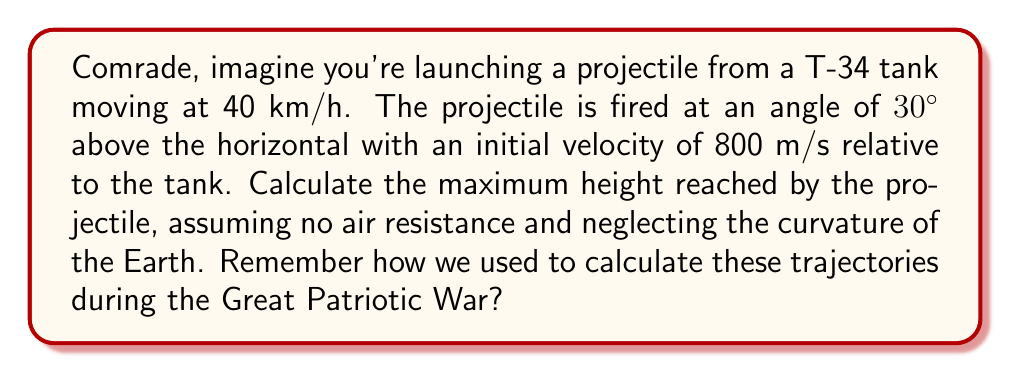Could you help me with this problem? Let's approach this step-by-step, tovarishch:

1) First, we need to determine the initial velocity components of the projectile relative to the ground. The tank's velocity adds to the horizontal component.

   Tank velocity: $v_t = 40 \text{ km/h} = 11.11 \text{ m/s}$
   
   Initial velocity components:
   $$v_{x0} = 800 \cos(30°) + 11.11 = 692.82 + 11.11 = 703.93 \text{ m/s}$$
   $$v_{y0} = 800 \sin(30°) = 400 \text{ m/s}$$

2) The maximum height is reached when the vertical velocity becomes zero. We can use the equation:
   $$v_y = v_{y0} - gt$$
   where $g$ is the acceleration due to gravity (9.8 m/s²).

3) At the highest point, $v_y = 0$, so:
   $$0 = 400 - 9.8t$$
   $$t = \frac{400}{9.8} = 40.82 \text{ s}$$

4) Now we can use the equation for displacement to find the maximum height:
   $$y = v_{y0}t - \frac{1}{2}gt^2$$

5) Substituting our values:
   $$y_{max} = 400(40.82) - \frac{1}{2}(9.8)(40.82)^2$$
   $$y_{max} = 16,328 - 8,164 = 8,164 \text{ m}$$

Thus, the projectile reaches a maximum height of 8,164 meters.
Answer: 8,164 m 